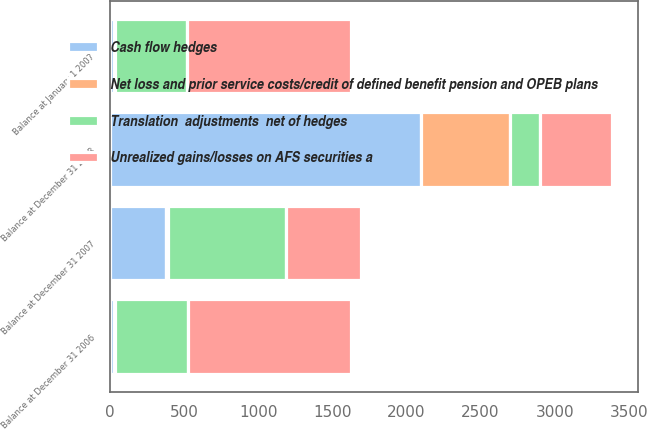Convert chart to OTSL. <chart><loc_0><loc_0><loc_500><loc_500><stacked_bar_chart><ecel><fcel>Balance at December 31 2006<fcel>Balance at January 1 2007<fcel>Balance at December 31 2007<fcel>Balance at December 31 2008<nl><fcel>Cash flow hedges<fcel>29<fcel>28<fcel>380<fcel>2101<nl><fcel>Net loss and prior service costs/credit of defined benefit pension and OPEB plans<fcel>5<fcel>5<fcel>8<fcel>598<nl><fcel>Translation  adjustments  net of hedges<fcel>489<fcel>489<fcel>802<fcel>202<nl><fcel>Unrealized gains/losses on AFS securities a<fcel>1102<fcel>1102<fcel>503<fcel>489<nl></chart> 